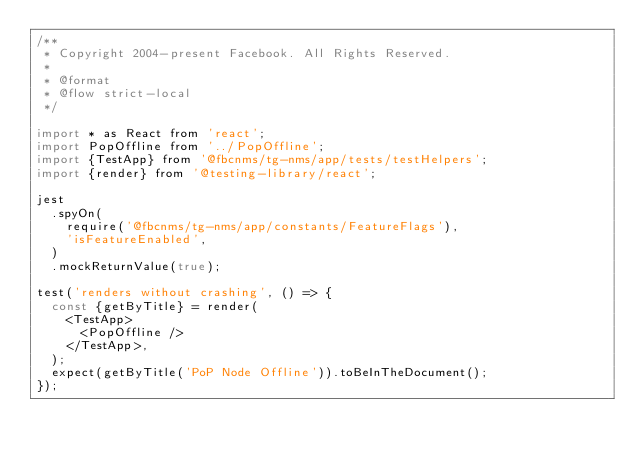Convert code to text. <code><loc_0><loc_0><loc_500><loc_500><_JavaScript_>/**
 * Copyright 2004-present Facebook. All Rights Reserved.
 *
 * @format
 * @flow strict-local
 */

import * as React from 'react';
import PopOffline from '../PopOffline';
import {TestApp} from '@fbcnms/tg-nms/app/tests/testHelpers';
import {render} from '@testing-library/react';

jest
  .spyOn(
    require('@fbcnms/tg-nms/app/constants/FeatureFlags'),
    'isFeatureEnabled',
  )
  .mockReturnValue(true);

test('renders without crashing', () => {
  const {getByTitle} = render(
    <TestApp>
      <PopOffline />
    </TestApp>,
  );
  expect(getByTitle('PoP Node Offline')).toBeInTheDocument();
});
</code> 